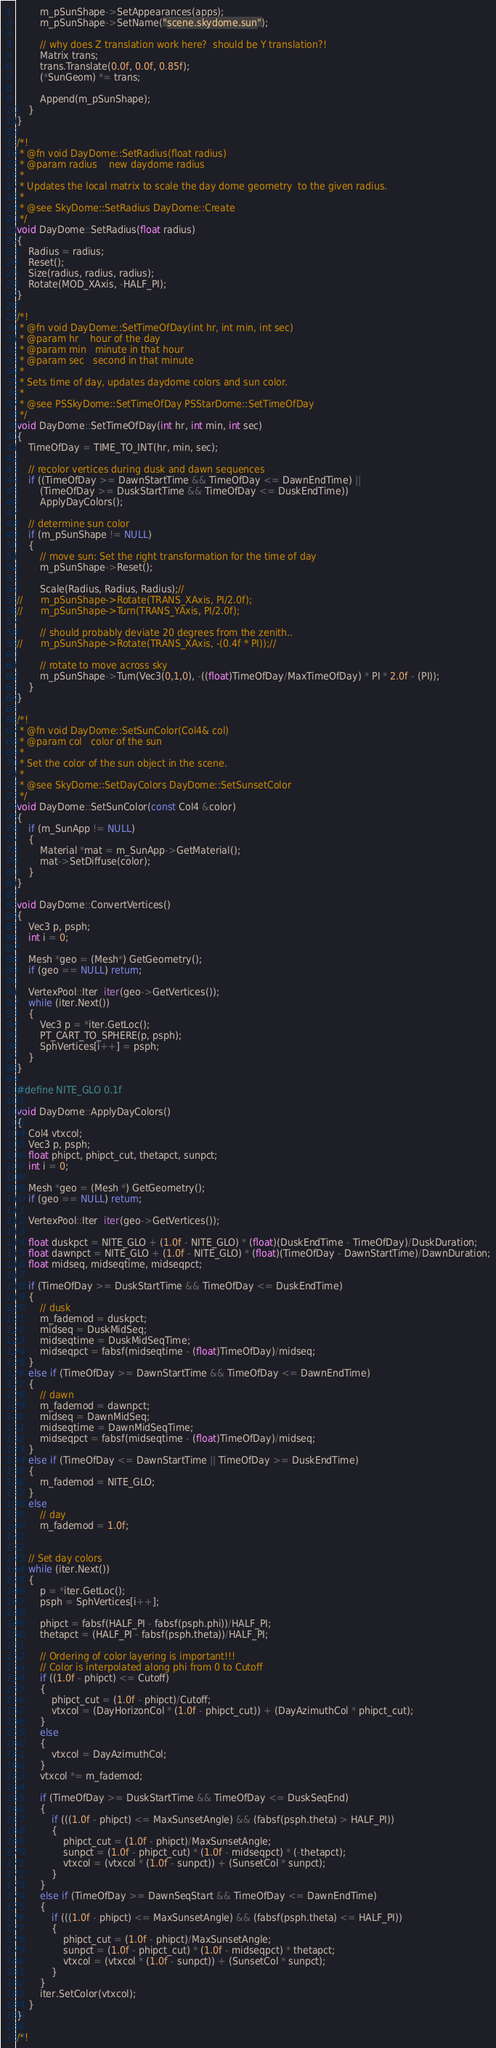<code> <loc_0><loc_0><loc_500><loc_500><_C++_>		m_pSunShape->SetAppearances(apps);
		m_pSunShape->SetName("scene.skydome.sun");

		// why does Z translation work here?  should be Y translation?!
		Matrix trans;
		trans.Translate(0.0f, 0.0f, 0.85f);
		(*SunGeom) *= trans;

		Append(m_pSunShape);
	}
}

/*!
 * @fn void DayDome::SetRadius(float radius)
 * @param radius	new daydome radius
 *
 * Updates the local matrix to scale the day dome geometry  to the given radius.
 *
 * @see SkyDome::SetRadius DayDome::Create
 */
void DayDome::SetRadius(float radius)
{
	Radius = radius;
	Reset();
	Size(radius, radius, radius);
	Rotate(MOD_XAxis, -HALF_PI);
}

/*!
 * @fn void DayDome::SetTimeOfDay(int hr, int min, int sec)
 * @param hr	hour of the day
 * @param min	minute in that hour
 * @param sec	second in that minute
 *
 * Sets time of day, updates daydome colors and sun color.
 *	
 * @see PSSkyDome::SetTimeOfDay PSStarDome::SetTimeOfDay
 */
void DayDome::SetTimeOfDay(int hr, int min, int sec)
{	
	TimeOfDay = TIME_TO_INT(hr, min, sec); 

	// recolor vertices during dusk and dawn sequences
	if ((TimeOfDay >= DawnStartTime && TimeOfDay <= DawnEndTime) ||
		(TimeOfDay >= DuskStartTime && TimeOfDay <= DuskEndTime))
		ApplyDayColors();

	// determine sun color
	if (m_pSunShape != NULL)
	{
		// move sun: Set the right transformation for the time of day
		m_pSunShape->Reset();

		Scale(Radius, Radius, Radius);//
//		m_pSunShape->Rotate(TRANS_XAxis, PI/2.0f);
//		m_pSunShape->Turn(TRANS_YAxis, PI/2.0f);

		// should probably deviate 20 degrees from the zenith..
//		m_pSunShape->Rotate(TRANS_XAxis, -(0.4f * PI));//

		// rotate to move across sky
		m_pSunShape->Turn(Vec3(0,1,0), -((float)TimeOfDay/MaxTimeOfDay) * PI * 2.0f - (PI));
	}
}

/*!
 * @fn void DayDome::SetSunColor(Col4& col)
 * @param col	color of the sun
 *
 * Set the color of the sun object in the scene.
 *	
 * @see SkyDome::SetDayColors DayDome::SetSunsetColor
 */
void DayDome::SetSunColor(const Col4 &color)
{
	if (m_SunApp != NULL)
	{
		Material *mat = m_SunApp->GetMaterial();
		mat->SetDiffuse(color);
	}
}

void DayDome::ConvertVertices()
{	
	Vec3 p, psph;
	int i = 0;

	Mesh *geo = (Mesh*) GetGeometry();
	if (geo == NULL) return;

	VertexPool::Iter  iter(geo->GetVertices()); 
	while (iter.Next())
	{
		Vec3 p = *iter.GetLoc();
		PT_CART_TO_SPHERE(p, psph);
		SphVertices[i++] = psph;
	}
}

#define NITE_GLO 0.1f

void DayDome::ApplyDayColors()
{
	Col4 vtxcol;
	Vec3 p, psph;
	float phipct, phipct_cut, thetapct, sunpct;
	int i = 0;

	Mesh *geo = (Mesh *) GetGeometry();
	if (geo == NULL) return;

	VertexPool::Iter  iter(geo->GetVertices());

	float duskpct = NITE_GLO + (1.0f - NITE_GLO) * (float)(DuskEndTime - TimeOfDay)/DuskDuration;
	float dawnpct = NITE_GLO + (1.0f - NITE_GLO) * (float)(TimeOfDay - DawnStartTime)/DawnDuration;
	float midseq, midseqtime, midseqpct;

	if (TimeOfDay >= DuskStartTime && TimeOfDay <= DuskEndTime) 
	{
		// dusk
		m_fademod = duskpct;
		midseq = DuskMidSeq;
		midseqtime = DuskMidSeqTime;
		midseqpct = fabsf(midseqtime - (float)TimeOfDay)/midseq;
	}
	else if (TimeOfDay >= DawnStartTime && TimeOfDay <= DawnEndTime)
	{
		// dawn
		m_fademod = dawnpct;
		midseq = DawnMidSeq;
		midseqtime = DawnMidSeqTime;
		midseqpct = fabsf(midseqtime - (float)TimeOfDay)/midseq;
	}
	else if (TimeOfDay <= DawnStartTime || TimeOfDay >= DuskEndTime)
	{
		m_fademod = NITE_GLO;
	}
	else
		// day
		m_fademod = 1.0f;


	// Set day colors
	while (iter.Next())
	{
		p = *iter.GetLoc();
		psph = SphVertices[i++];

		phipct = fabsf(HALF_PI - fabsf(psph.phi))/HALF_PI;
		thetapct = (HALF_PI - fabsf(psph.theta))/HALF_PI;

		// Ordering of color layering is important!!!
		// Color is interpolated along phi from 0 to Cutoff
		if ((1.0f - phipct) <= Cutoff)
		{
			phipct_cut = (1.0f - phipct)/Cutoff;
			vtxcol = (DayHorizonCol * (1.0f - phipct_cut)) + (DayAzimuthCol * phipct_cut);
		}
		else
		{
			vtxcol = DayAzimuthCol;
		}
		vtxcol *= m_fademod;

		if (TimeOfDay >= DuskStartTime && TimeOfDay <= DuskSeqEnd)
		{
			if (((1.0f - phipct) <= MaxSunsetAngle) && (fabsf(psph.theta) > HALF_PI))
			{
				phipct_cut = (1.0f - phipct)/MaxSunsetAngle;
				sunpct = (1.0f - phipct_cut) * (1.0f - midseqpct) * (-thetapct);
				vtxcol = (vtxcol * (1.0f - sunpct)) + (SunsetCol * sunpct);
			}
		}
		else if (TimeOfDay >= DawnSeqStart && TimeOfDay <= DawnEndTime)
		{	
			if (((1.0f - phipct) <= MaxSunsetAngle) && (fabsf(psph.theta) <= HALF_PI))
			{
				phipct_cut = (1.0f - phipct)/MaxSunsetAngle;
				sunpct = (1.0f - phipct_cut) * (1.0f - midseqpct) * thetapct;
				vtxcol = (vtxcol * (1.0f - sunpct)) + (SunsetCol * sunpct);
			}
		}
		iter.SetColor(vtxcol);
	}
}

/*!</code> 